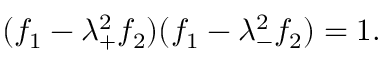Convert formula to latex. <formula><loc_0><loc_0><loc_500><loc_500>( f _ { 1 } - \lambda _ { + } ^ { 2 } f _ { 2 } ) ( f _ { 1 } - \lambda _ { - } ^ { 2 } f _ { 2 } ) = 1 .</formula> 